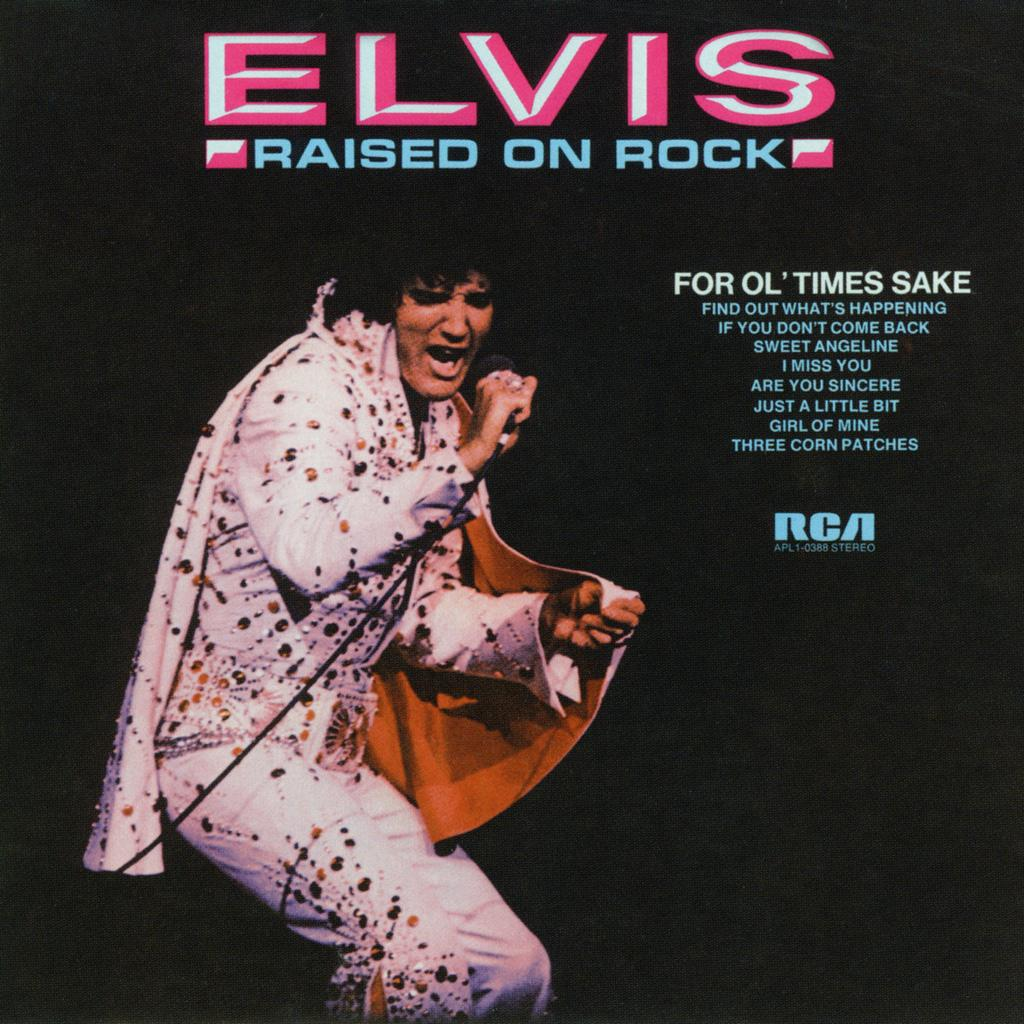What is the main subject of the image? There is a person in the image. What is the person wearing? The person is wearing a white dress. What is the person doing in the image? The person is singing. What object is the person holding? The person is holding a microphone. What color is the background of the image? The background of the image is black. What substance is being folded in the image? There is no substance being folded in the image; it features a person singing while holding a microphone. What grade is the person in, based on the image? There is no indication of the person's grade in the image; it only shows them singing while holding a microphone. 